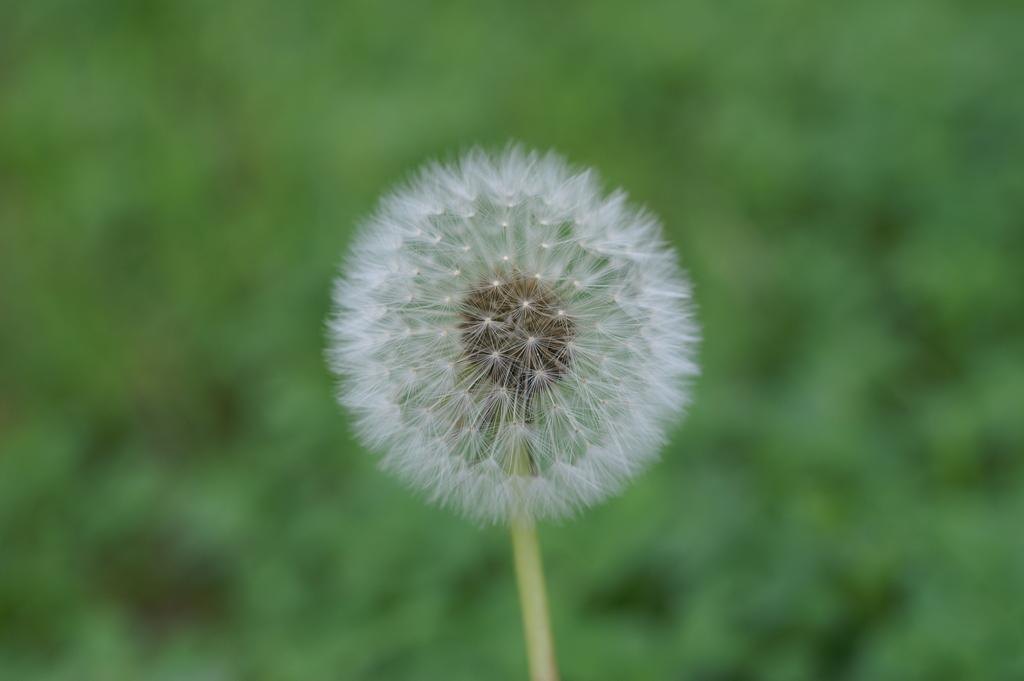What type of flower is in the image? There is a white color flower in the image. What color is the background of the image? The background of the image is green. How is the background of the image depicted? The background is blurred. What hobbies do the sisters in the image enjoy? There are no sisters or hobbies mentioned in the image; it only features a white color flower and a green background. 